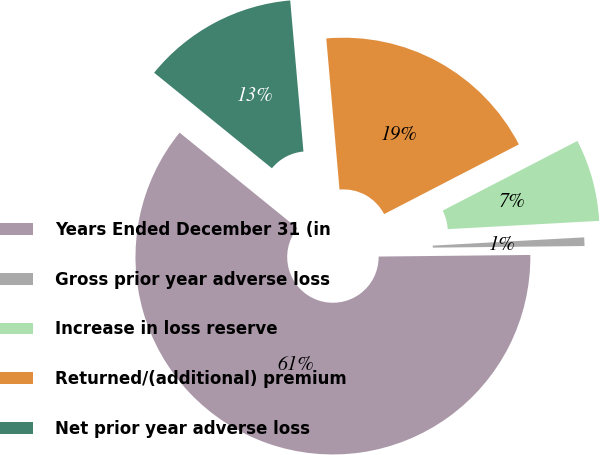Convert chart to OTSL. <chart><loc_0><loc_0><loc_500><loc_500><pie_chart><fcel>Years Ended December 31 (in<fcel>Gross prior year adverse loss<fcel>Increase in loss reserve<fcel>Returned/(additional) premium<fcel>Net prior year adverse loss<nl><fcel>61.01%<fcel>0.7%<fcel>6.73%<fcel>18.79%<fcel>12.76%<nl></chart> 